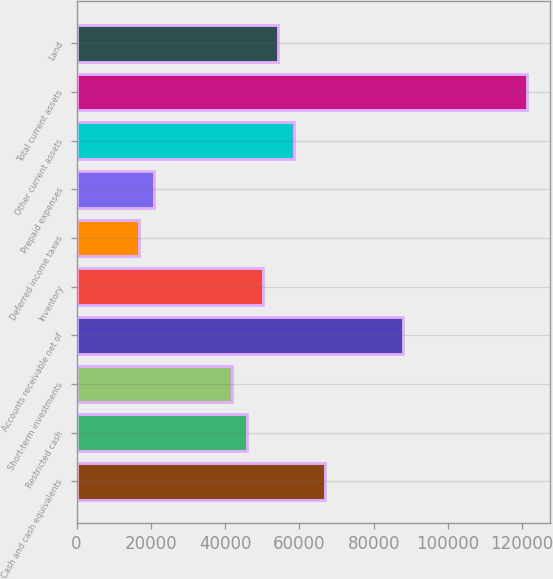Convert chart. <chart><loc_0><loc_0><loc_500><loc_500><bar_chart><fcel>Cash and cash equivalents<fcel>Restricted cash<fcel>Short-term investments<fcel>Accounts receivable net of<fcel>Inventory<fcel>Deferred income taxes<fcel>Prepaid expenses<fcel>Other current assets<fcel>Total current assets<fcel>Land<nl><fcel>66923.2<fcel>46012.2<fcel>41830<fcel>87834.2<fcel>50194.4<fcel>16736.8<fcel>20919<fcel>58558.8<fcel>121292<fcel>54376.6<nl></chart> 